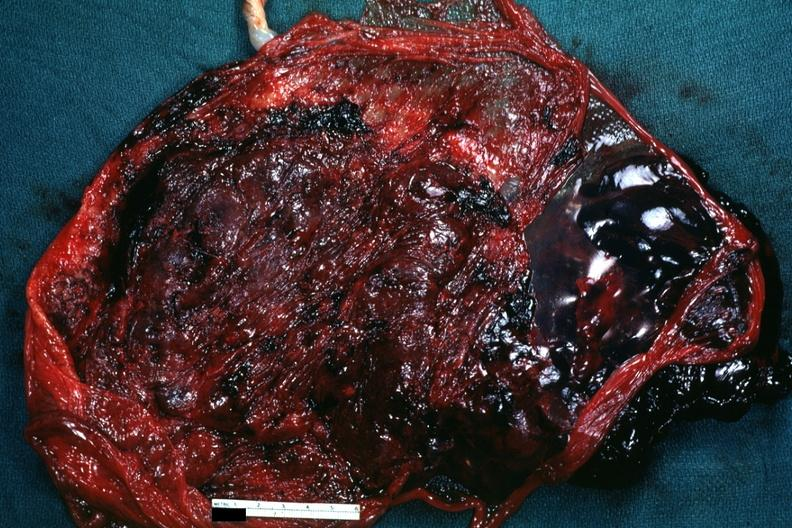does this image show maternal surface with blood clot?
Answer the question using a single word or phrase. Yes 